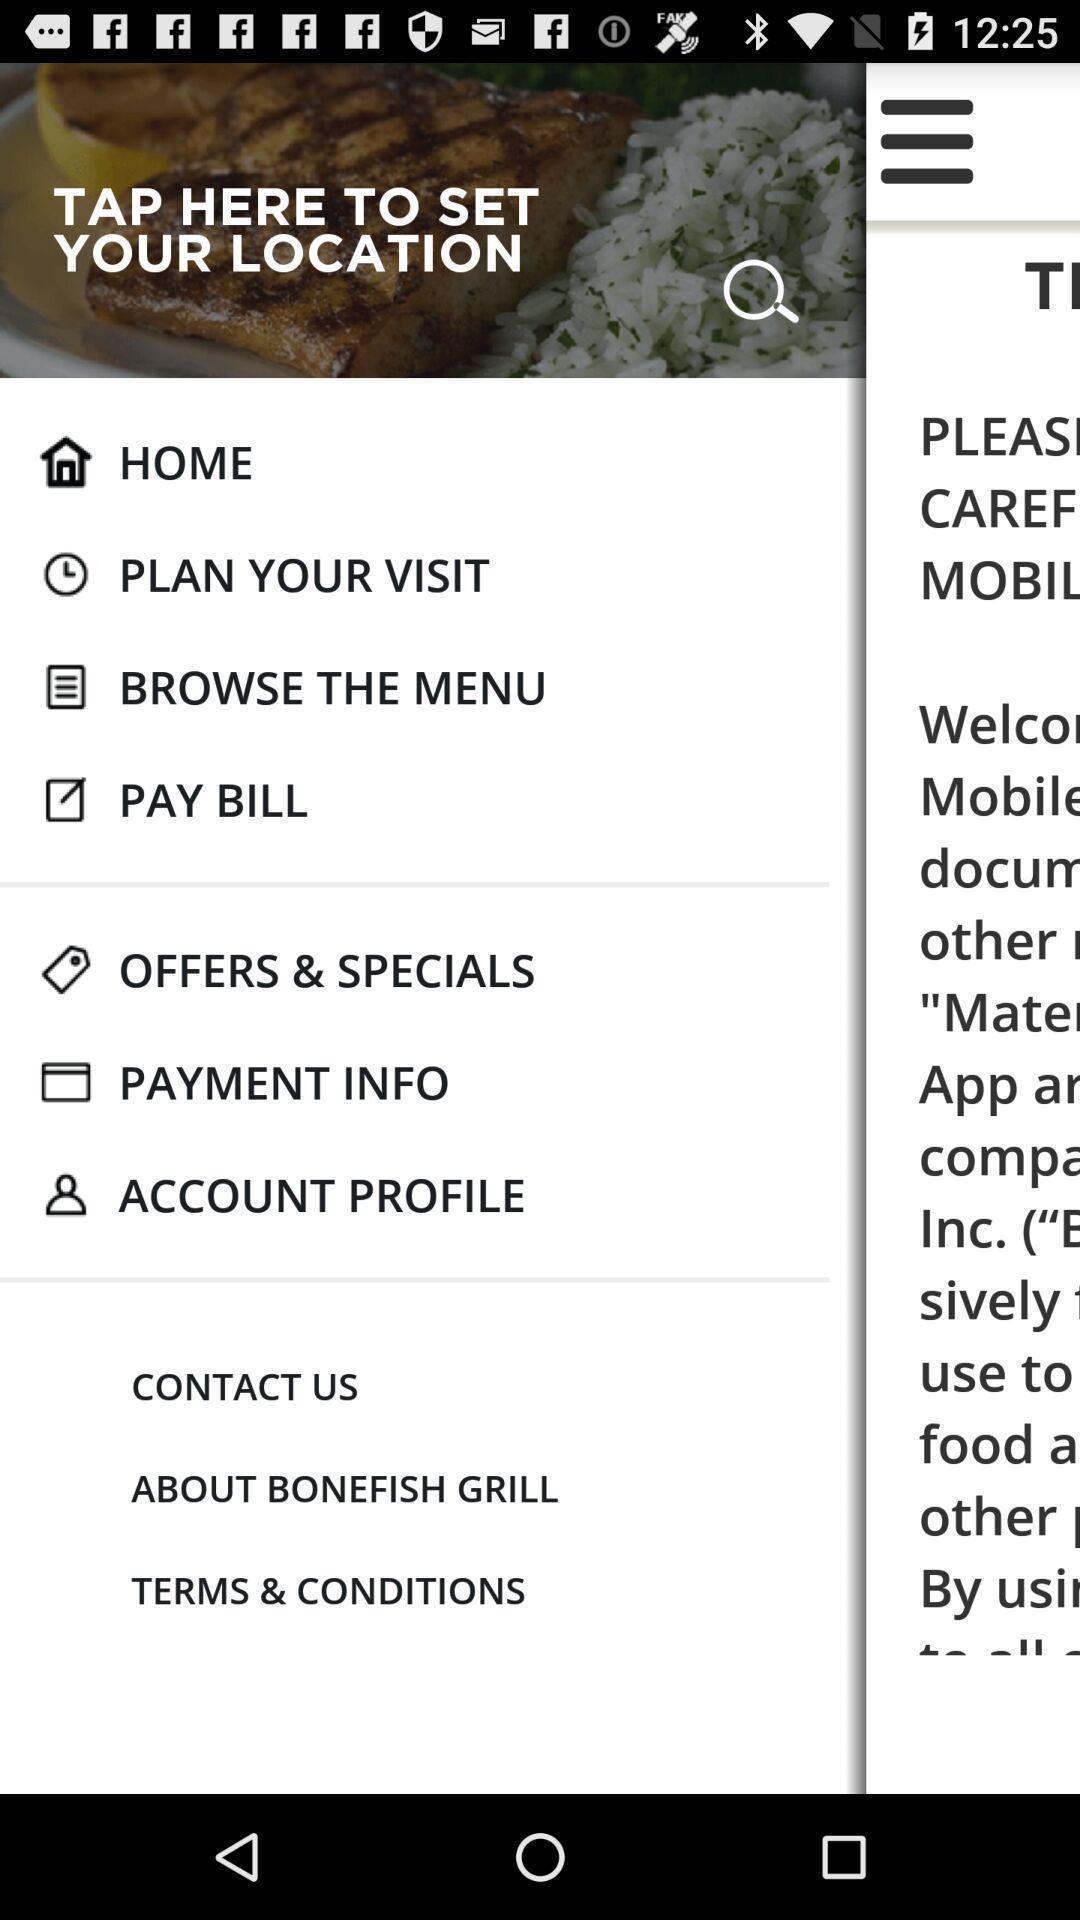Provide a description of this screenshot. Screen shows to set a location for a food app. 